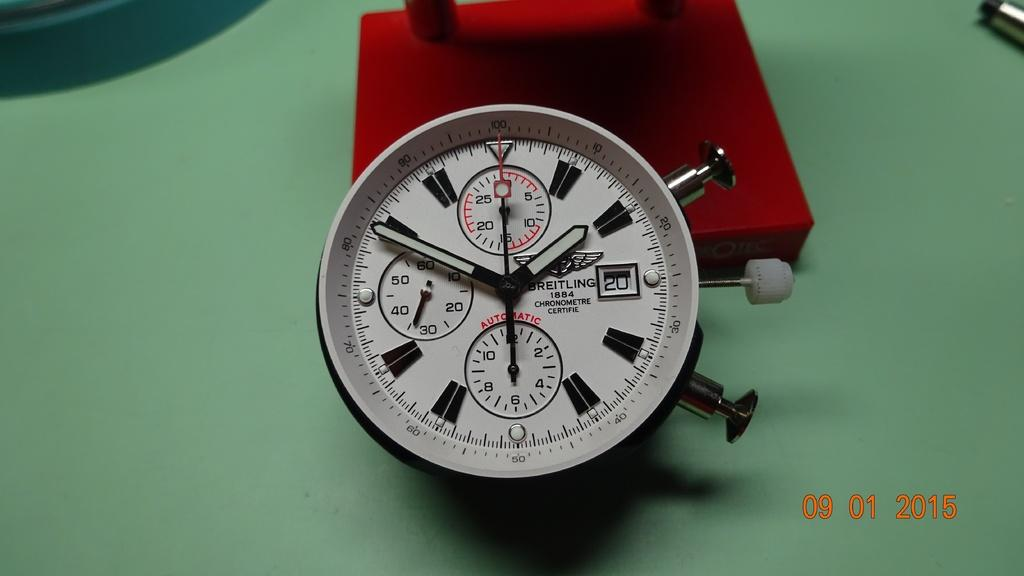<image>
Render a clear and concise summary of the photo. A Breitling gauge rests on a green table. 